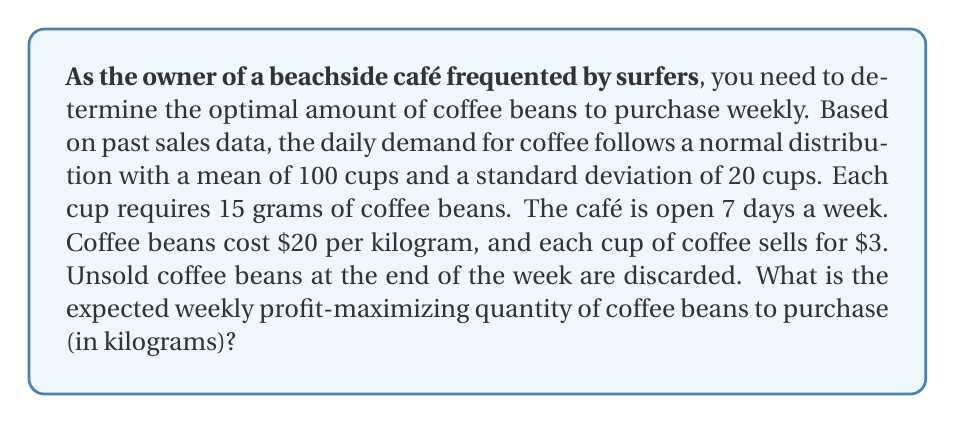Teach me how to tackle this problem. Let's approach this step-by-step:

1) First, we need to calculate the weekly demand distribution:
   - Daily demand: $\mu = 100$, $\sigma = 20$
   - Weekly demand: $\mu_w = 7 * 100 = 700$, $\sigma_w = \sqrt{7} * 20 \approx 52.92$

2) Convert cups to kilograms of coffee beans:
   - 15 grams per cup = 0.015 kg per cup
   - Weekly mean in kg: $700 * 0.015 = 10.5$ kg
   - Weekly standard deviation in kg: $52.92 * 0.015 \approx 0.79$ kg

3) Let $Q$ be the quantity ordered (in kg), and $X$ be the random demand (in kg).
   The expected profit function is:

   $$E[P(Q)] = 3 * (66.67Q) - 20Q - 3 * 66.67 * E[\max(0, X-Q)]$$

   Where $66.67$ is the number of cups per kg (1000g / 15g).

4) The optimal $Q$ satisfies:

   $$P(X \leq Q) = \frac{3 * 66.67 - 20}{3 * 66.67} \approx 0.9$$

5) Using the standard normal distribution:

   $$\frac{Q - 10.5}{0.79} = z_{0.9} \approx 1.28$$

6) Solving for $Q$:

   $$Q = 10.5 + 1.28 * 0.79 \approx 11.51$$ kg

Therefore, the optimal weekly purchase quantity is approximately 11.51 kg of coffee beans.
Answer: 11.51 kg 